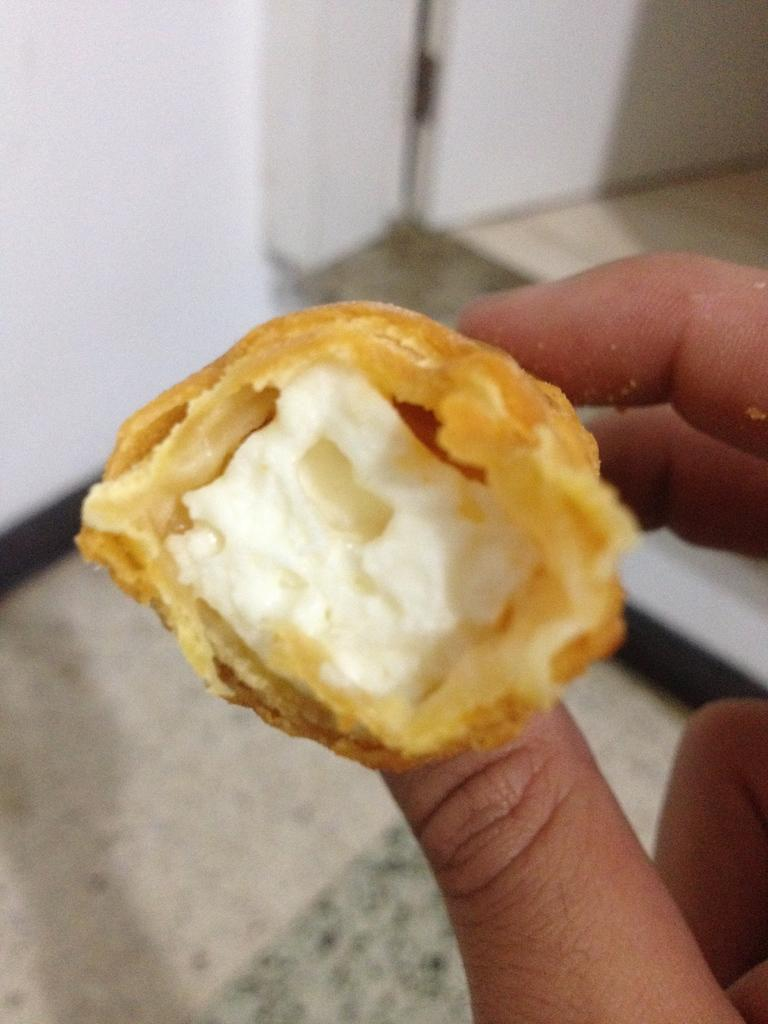What is the person holding in the image? The person is holding a food item in the image. Can you describe the appearance of the food item? The food item has white and brown colors. What can be seen in the background of the image? There is a floor and a wall visible in the background of the image. How many bulbs are hanging from the ceiling in the image? There are no bulbs visible in the image; only the person, the food item, the floor, and the wall are present. 